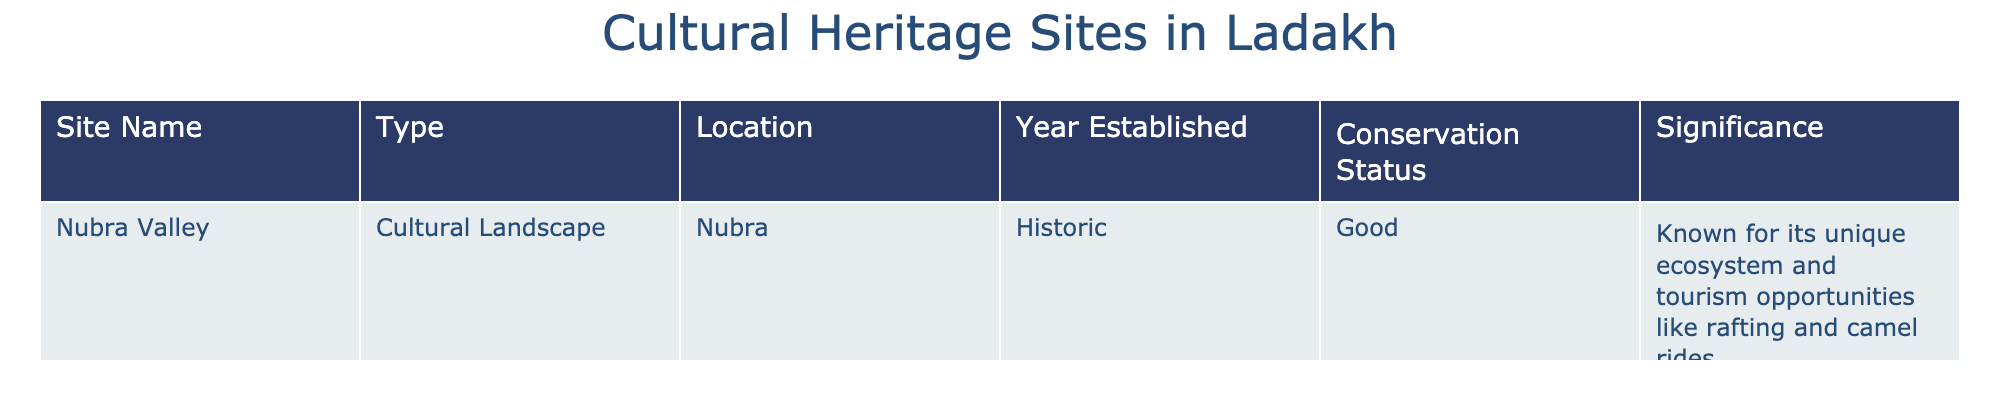What is the name of the cultural landscape located in Nubra? The table lists "Nubra Valley" as the only entry under "Site Name". Therefore, Nubra Valley is the cultural landscape located in Nubra.
Answer: Nubra Valley What is the conservation status of Nubra Valley? The table explicitly states that the conservation status of Nubra Valley is "Good".
Answer: Good In which year was Nubra Valley established? From the table, it indicates that Nubra Valley was established in a historic year, but does not provide a specific year. Therefore, we conclude "Historic" is the information given.
Answer: Historic Is Nubra Valley known for its unique ecosystem? Based on the significance provided in the table, it states that Nubra Valley is known for its unique ecosystem. Hence, the answer is yes.
Answer: Yes How many unique features are mentioned in relation to Nubra Valley's significance? The table lists two features: its unique ecosystem and tourism opportunities like rafting and camel rides. Therefore, the total is two unique features related to its significance.
Answer: 2 What is the location of Nubra Valley? The table specifies that Nubra Valley is located in "Nubra", directly answering the location question.
Answer: Nubra Does the table include any cultural heritage sites in Ladakh other than Nubra Valley? The current data only includes Nubra Valley, indicating no other cultural heritage sites are mentioned in the table at this time. Thus, the answer is no.
Answer: No What type of site is Nubra Valley classified as? The table categorizes Nubra Valley under the type "Cultural Landscape". Therefore, this is the classification.
Answer: Cultural Landscape 